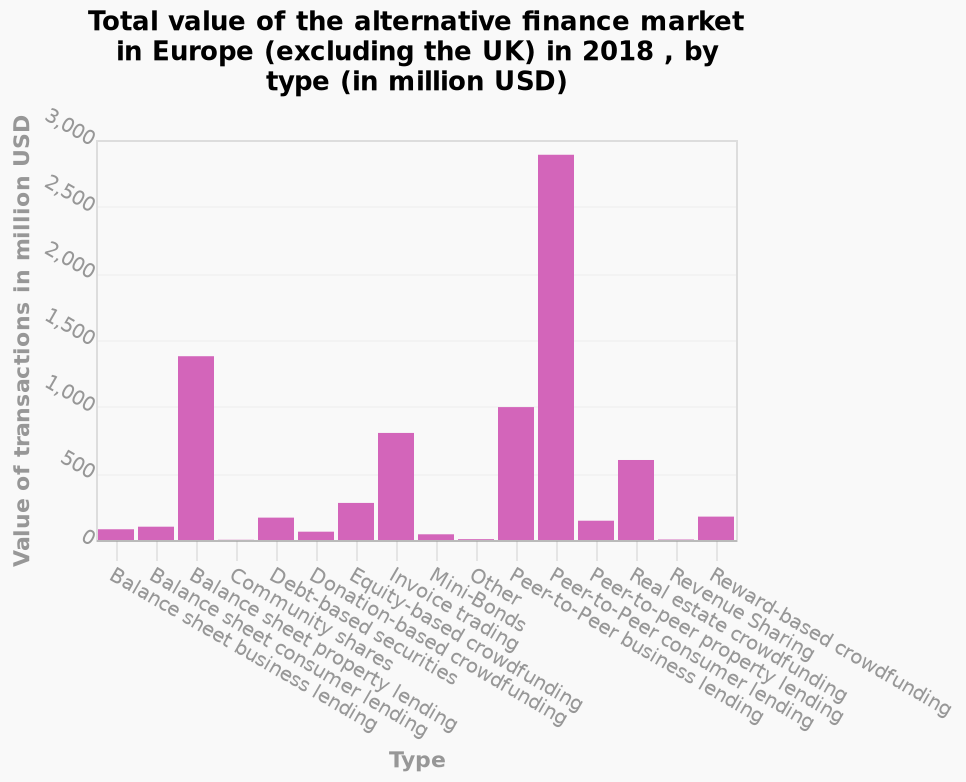<image>
please summary the statistics and relations of the chart In 2018 peer to peer consumer lending was the highest value alternative finance market in Europe at almost 3,000,000,000 USDThe second highest value market was Balance sheet property lending at just under 1,500,000,000 USD about half the value of the highest value market. Community shares, Other and Revenue sharing were the least valuable alternative finance markets in Europe during 2018. What does the y-axis represent on the bar chart?  The y-axis represents the value of transactions in million USD, using a linear scale ranging from 0 to 3,000. What is the range of values shown on the y-axis? The range of values shown on the y-axis is from 0 to 3,000 million USD. What is the value of the majority of alternative finances? The majority of alternative finances have a value of less than five hundred million USD. 